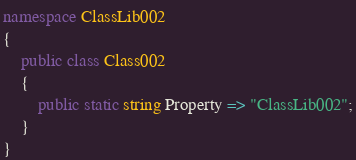<code> <loc_0><loc_0><loc_500><loc_500><_C#_>namespace ClassLib002
{
    public class Class002
    {
        public static string Property => "ClassLib002";
    }
}
</code> 